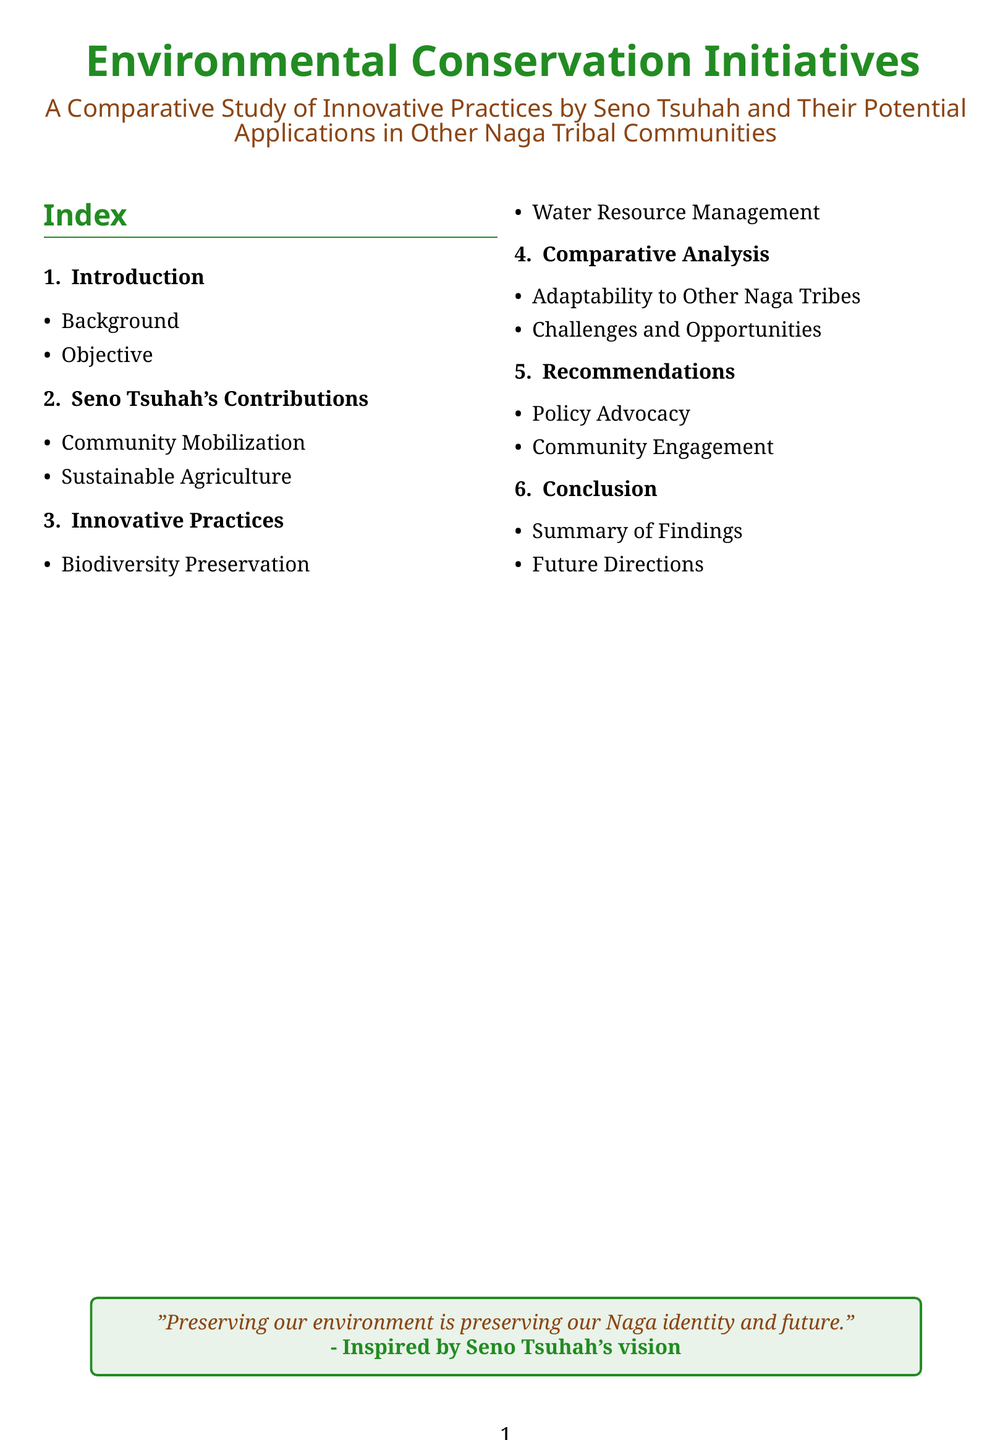what is the title of the document? The title of the document is prominently displayed in the header, indicating its focus and scope.
Answer: Environmental Conservation Initiatives who is the primary activist mentioned? The document highlights the contributions of a specific activist, emphasizing their initiatives in environmental conservation.
Answer: Seno Tsuhah how many sections are in the index? The index outlines several key components, organized clearly for easy navigation.
Answer: six what is one area of Seno Tsuhah's contributions? The document lists various contributions of Seno Tsuhah, reflecting their impact on community and environment.
Answer: Community Mobilization what type of management practice is highlighted in the innovative practices section? This section focuses on specific techniques that contribute to environmental sustainability within the community.
Answer: Water Resource Management what two themes are explored in the comparative analysis? The analysis provides insights into the adaptability of practices and the context of other tribal communities.
Answer: Adaptability to Other Naga Tribes, Challenges and Opportunities what does the concluding section summarize? The conclusion of the document wraps up the findings and reflects on future possibilities related to the topic.
Answer: Summary of Findings what is the color scheme used for the section titles? The visual design and color scheme chosen for section headings play a significant role in the document's aesthetic.
Answer: Nagagreen and Nagabrown 